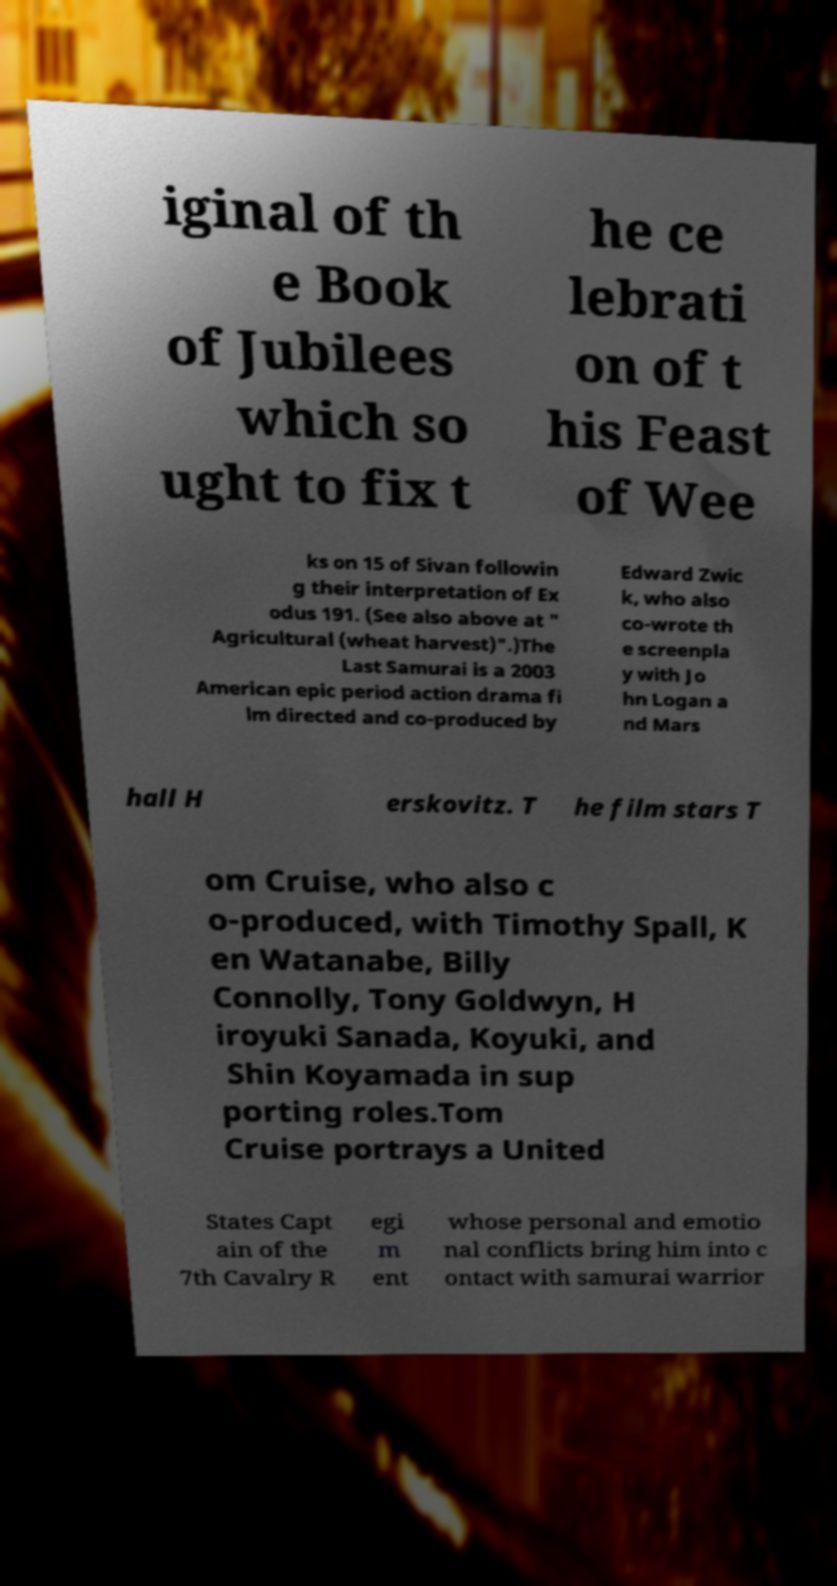Please read and relay the text visible in this image. What does it say? iginal of th e Book of Jubilees which so ught to fix t he ce lebrati on of t his Feast of Wee ks on 15 of Sivan followin g their interpretation of Ex odus 191. (See also above at " Agricultural (wheat harvest)".)The Last Samurai is a 2003 American epic period action drama fi lm directed and co-produced by Edward Zwic k, who also co-wrote th e screenpla y with Jo hn Logan a nd Mars hall H erskovitz. T he film stars T om Cruise, who also c o-produced, with Timothy Spall, K en Watanabe, Billy Connolly, Tony Goldwyn, H iroyuki Sanada, Koyuki, and Shin Koyamada in sup porting roles.Tom Cruise portrays a United States Capt ain of the 7th Cavalry R egi m ent whose personal and emotio nal conflicts bring him into c ontact with samurai warrior 